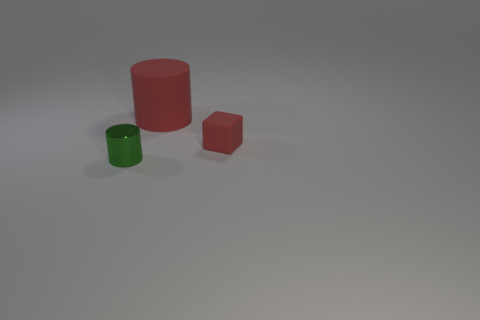There is a tiny object on the left side of the big thing; what is its shape?
Make the answer very short. Cylinder. How many objects are behind the green shiny cylinder and in front of the big object?
Make the answer very short. 1. Are there any tiny blue cylinders made of the same material as the tiny green cylinder?
Provide a short and direct response. No. There is a rubber object that is the same color as the tiny cube; what size is it?
Offer a terse response. Large. What number of spheres are metallic things or large yellow things?
Make the answer very short. 0. What size is the green cylinder?
Make the answer very short. Small. How many green shiny cylinders are right of the small cube?
Provide a succinct answer. 0. What is the size of the cylinder on the right side of the cylinder that is on the left side of the large rubber cylinder?
Provide a short and direct response. Large. There is a red object in front of the big red matte object; is it the same shape as the tiny object on the left side of the red matte block?
Provide a succinct answer. No. There is a tiny red rubber object that is in front of the red object on the left side of the red block; what is its shape?
Offer a terse response. Cube. 